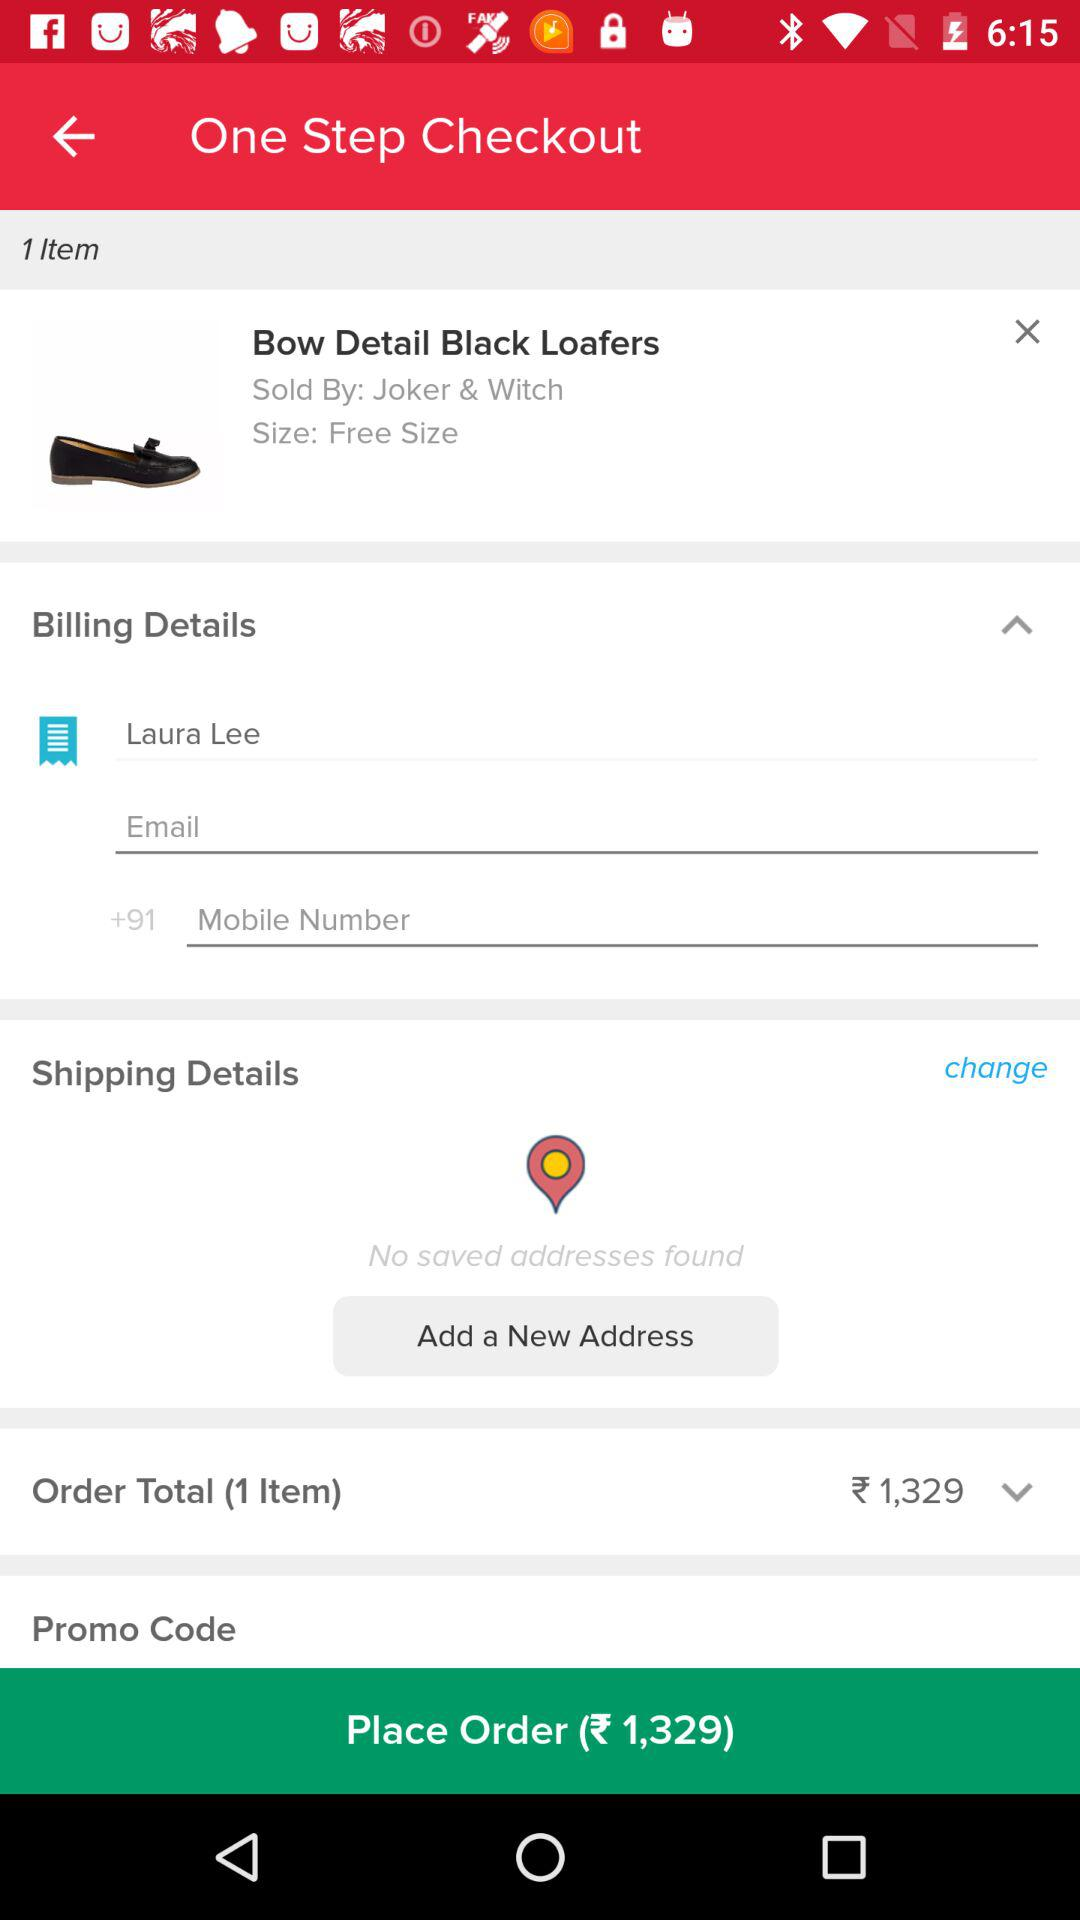What is the price of the shoes? The price is ₹1,329. 